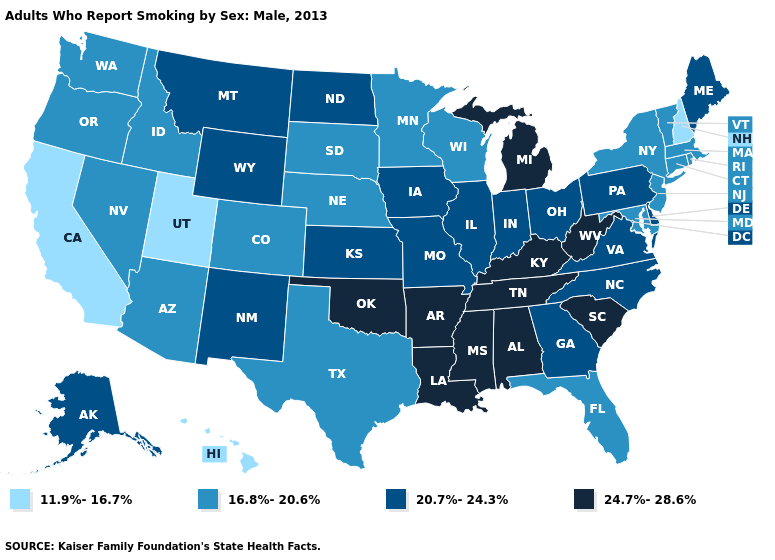Among the states that border Illinois , does Wisconsin have the lowest value?
Keep it brief. Yes. Does Hawaii have the lowest value in the USA?
Answer briefly. Yes. Name the states that have a value in the range 11.9%-16.7%?
Short answer required. California, Hawaii, New Hampshire, Utah. Name the states that have a value in the range 24.7%-28.6%?
Keep it brief. Alabama, Arkansas, Kentucky, Louisiana, Michigan, Mississippi, Oklahoma, South Carolina, Tennessee, West Virginia. How many symbols are there in the legend?
Keep it brief. 4. Name the states that have a value in the range 11.9%-16.7%?
Give a very brief answer. California, Hawaii, New Hampshire, Utah. What is the value of Mississippi?
Keep it brief. 24.7%-28.6%. Name the states that have a value in the range 20.7%-24.3%?
Give a very brief answer. Alaska, Delaware, Georgia, Illinois, Indiana, Iowa, Kansas, Maine, Missouri, Montana, New Mexico, North Carolina, North Dakota, Ohio, Pennsylvania, Virginia, Wyoming. Name the states that have a value in the range 11.9%-16.7%?
Short answer required. California, Hawaii, New Hampshire, Utah. Which states have the highest value in the USA?
Write a very short answer. Alabama, Arkansas, Kentucky, Louisiana, Michigan, Mississippi, Oklahoma, South Carolina, Tennessee, West Virginia. Does Pennsylvania have a lower value than Tennessee?
Give a very brief answer. Yes. What is the highest value in the USA?
Give a very brief answer. 24.7%-28.6%. Name the states that have a value in the range 24.7%-28.6%?
Be succinct. Alabama, Arkansas, Kentucky, Louisiana, Michigan, Mississippi, Oklahoma, South Carolina, Tennessee, West Virginia. Which states have the lowest value in the West?
Be succinct. California, Hawaii, Utah. What is the highest value in the USA?
Quick response, please. 24.7%-28.6%. 